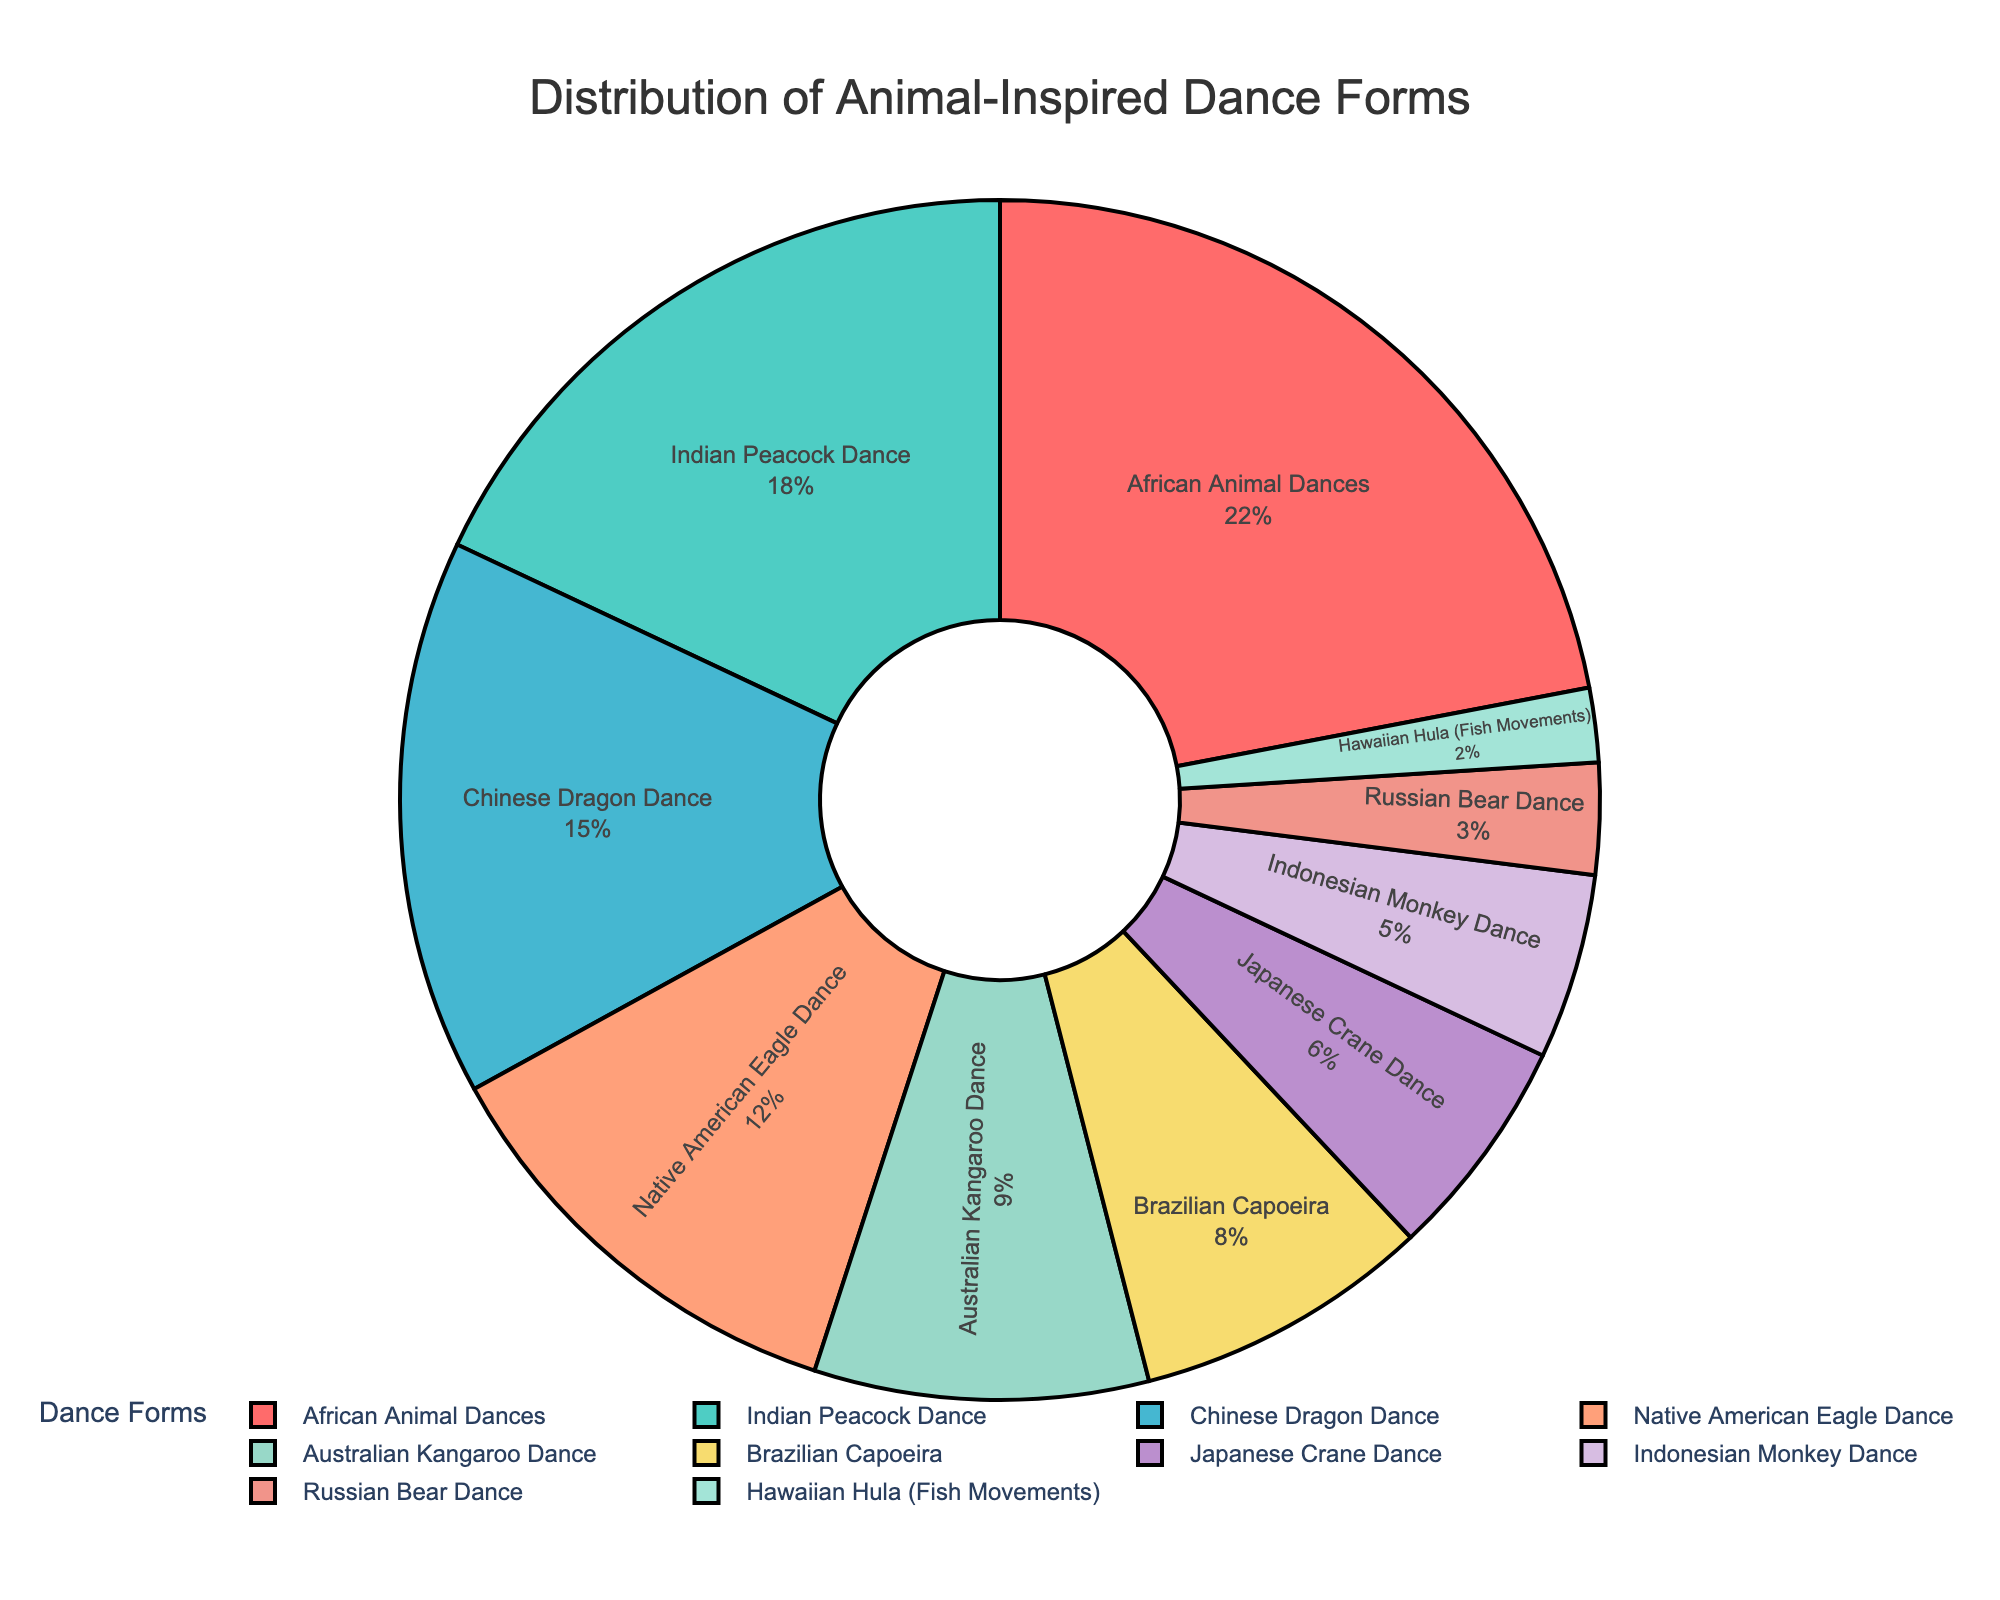Which dance form has the highest percentage? The pie chart shows various percentages, and the highest one is represented by the African Animal Dances segment with 22%.
Answer: African Animal Dances Which two dance forms together make up exactly 30%? By looking at the segments, the Indian Peacock Dance is 18% and the Native American Eagle Dance is 12%. Adding these percentages together (18% + 12%) equals 30%.
Answer: Indian Peacock Dance and Native American Eagle Dance How much larger is the percentage for Chinese Dragon Dance compared to Brazilian Capoeira? The Chinese Dragon Dance has 15% and Brazilian Capoeira has 8%. The difference is calculated by subtracting the smaller percentage from the larger one: 15% - 8% = 7%.
Answer: 7% What is the combined percentage of the bottom three dance forms? The bottom three dance forms are Hawaiian Hula (2%), Russian Bear Dance (3%), and Indonesian Monkey Dance (5%). Summing these, we have 2% + 3% + 5% = 10%.
Answer: 10% Which segment is represented by a blue color in the pie chart? Examining the colors of the segments, the blue segment corresponds to Indian Peacock Dance.
Answer: Indian Peacock Dance Is the percentage of African Animal Dances greater than the combined percentage of Japanese Crane Dance and Indonesian Monkey Dance? The percentage for African Animal Dances is 22%. Japanese Crane Dance is 6% and Indonesian Monkey Dance is 5%, summing these gives 6% + 5% = 11%. Since 22% is greater than 11%, the statement is true.
Answer: Yes What percentage of dance forms are inspired by flying animals? The flying animals in the chart are represented by Indian Peacock Dance (18%), Chinese Dragon Dance (15%), and Native American Eagle Dance (12%). Summing these percentages: 18% + 15% + 12% = 45%.
Answer: 45% How many dance forms have a percentage less than 10%? From the chart, the dance forms with less than 10% are Australian Kangaroo Dance (9%), Brazilian Capoeira (8%), Japanese Crane Dance (6%), Indonesian Monkey Dance (5%), Russian Bear Dance (3%), and Hawaiian Hula (2%). Counting these gives us 6 dance forms.
Answer: 6 What is the percentage difference between Australian Kangaroo Dance and Native American Eagle Dance? Australian Kangaroo Dance is 9% and Native American Eagle Dance is 12%. The difference is 12% - 9% = 3%.
Answer: 3% What are the two segments with the closest percentages? Looking at the chart, Japanese Crane Dance (6%) and Indonesian Monkey Dance (5%) have the closest percentages, with a difference of only 1%.
Answer: Japanese Crane Dance and Indonesian Monkey Dance 